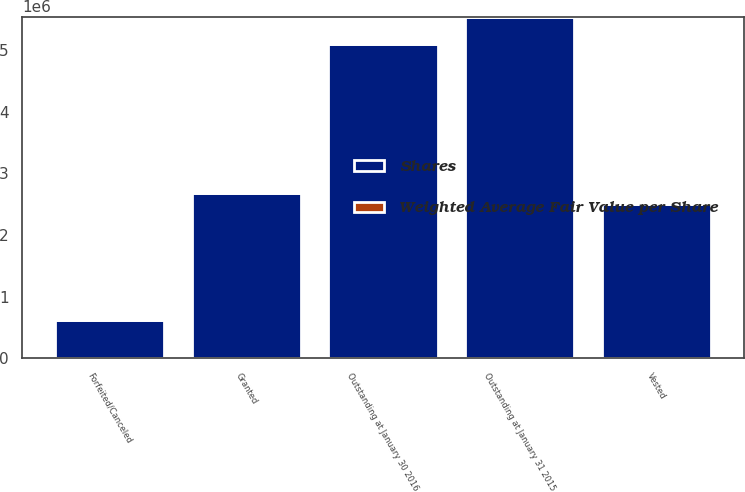<chart> <loc_0><loc_0><loc_500><loc_500><stacked_bar_chart><ecel><fcel>Outstanding at January 31 2015<fcel>Granted<fcel>Vested<fcel>Forfeited/Canceled<fcel>Outstanding at January 30 2016<nl><fcel>Shares<fcel>5.543e+06<fcel>2.683e+06<fcel>2.503e+06<fcel>620000<fcel>5.103e+06<nl><fcel>Weighted Average Fair Value per Share<fcel>24.4<fcel>38.72<fcel>23.1<fcel>29.98<fcel>31.89<nl></chart> 